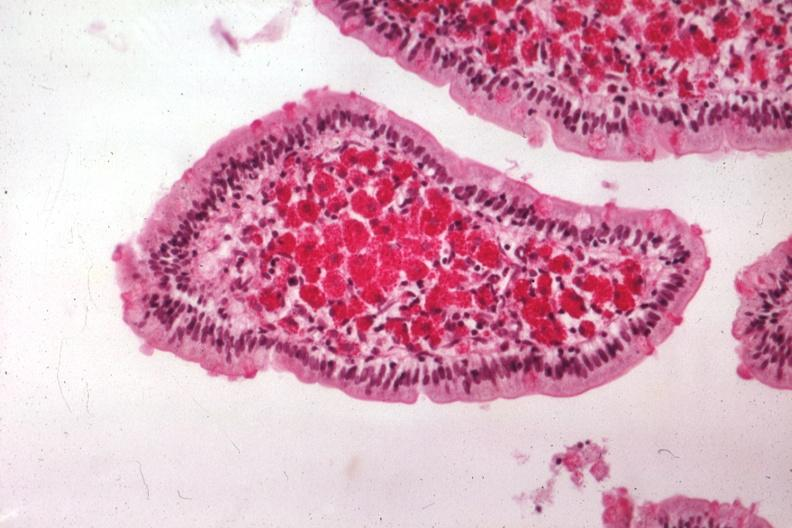does this image show med pas hematoxylin excellent demonstration source?
Answer the question using a single word or phrase. Yes 